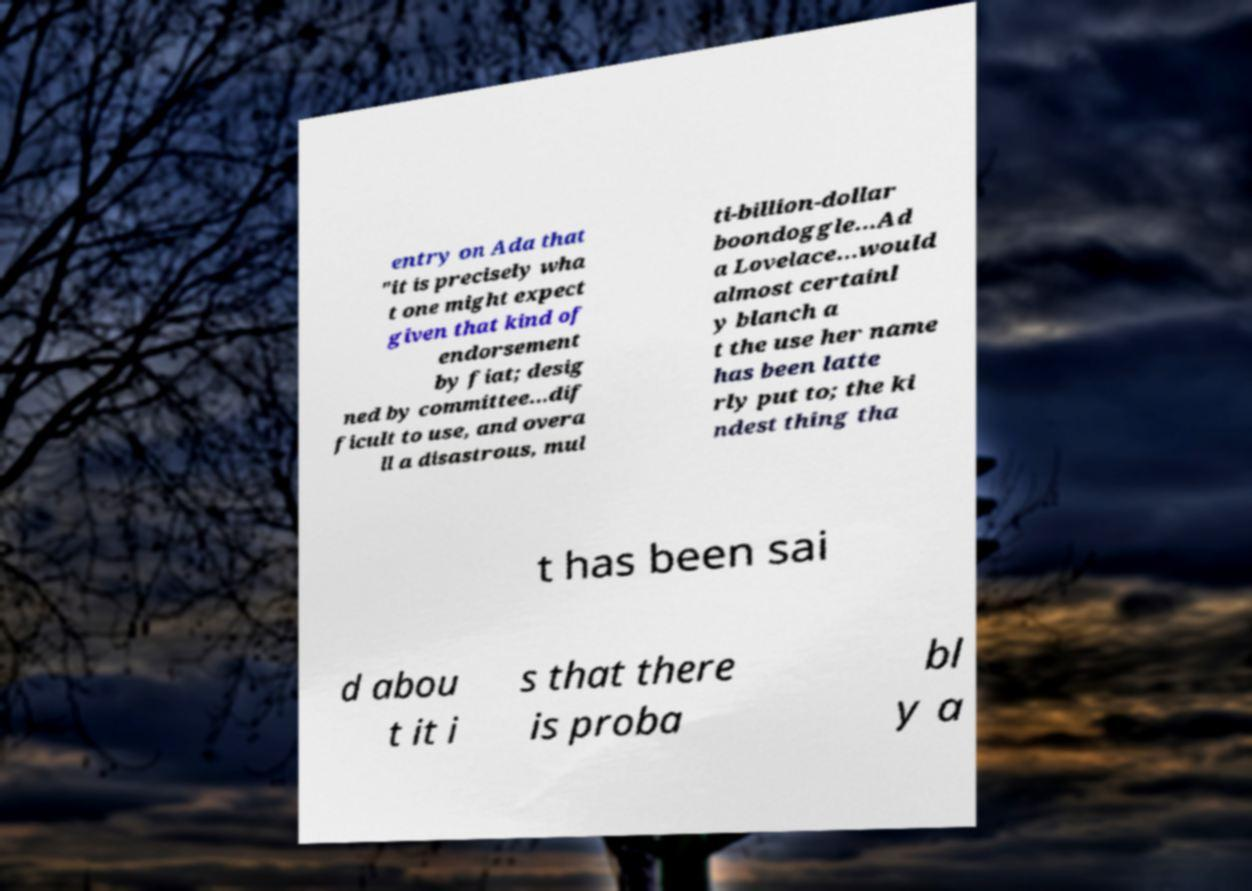There's text embedded in this image that I need extracted. Can you transcribe it verbatim? entry on Ada that "it is precisely wha t one might expect given that kind of endorsement by fiat; desig ned by committee...dif ficult to use, and overa ll a disastrous, mul ti-billion-dollar boondoggle...Ad a Lovelace...would almost certainl y blanch a t the use her name has been latte rly put to; the ki ndest thing tha t has been sai d abou t it i s that there is proba bl y a 